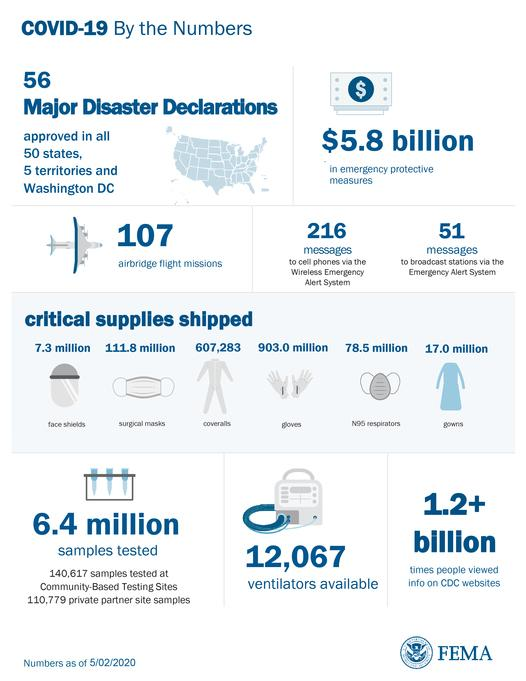Indicate a few pertinent items in this graphic. In total, 6.4 million samples were tested. As of our current records, a total of 17.0 million gowns have been shipped. The total count of face shields and gowns shipped was 24.3 million. 78.5 million units of N95 respirators were shipped. The wireless emergency alert system has received 216 messages. 